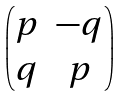Convert formula to latex. <formula><loc_0><loc_0><loc_500><loc_500>\begin{pmatrix} p & - q \\ q & p \end{pmatrix}</formula> 